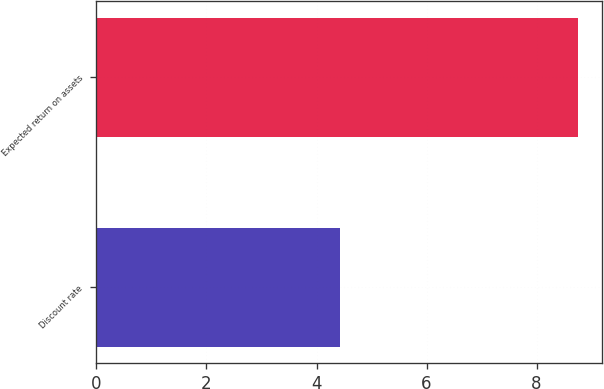<chart> <loc_0><loc_0><loc_500><loc_500><bar_chart><fcel>Discount rate<fcel>Expected return on assets<nl><fcel>4.42<fcel>8.75<nl></chart> 